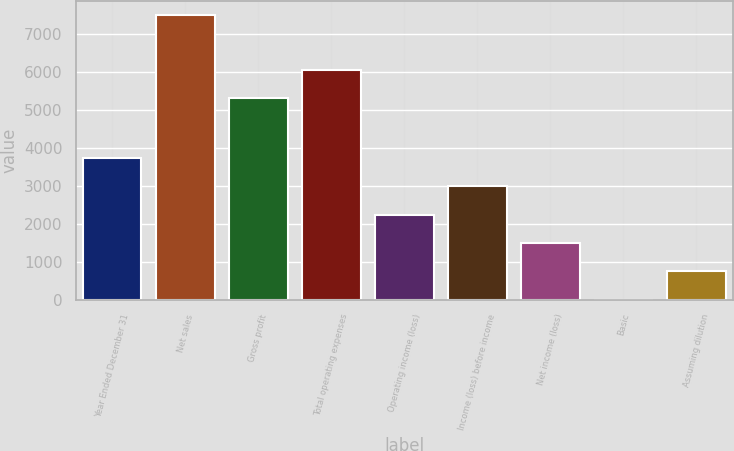Convert chart. <chart><loc_0><loc_0><loc_500><loc_500><bar_chart><fcel>Year Ended December 31<fcel>Net sales<fcel>Gross profit<fcel>Total operating expenses<fcel>Operating income (loss)<fcel>Income (loss) before income<fcel>Net income (loss)<fcel>Basic<fcel>Assuming dilution<nl><fcel>3738.58<fcel>7477<fcel>5304<fcel>6051.68<fcel>2243.22<fcel>2990.9<fcel>1495.54<fcel>0.18<fcel>747.86<nl></chart> 